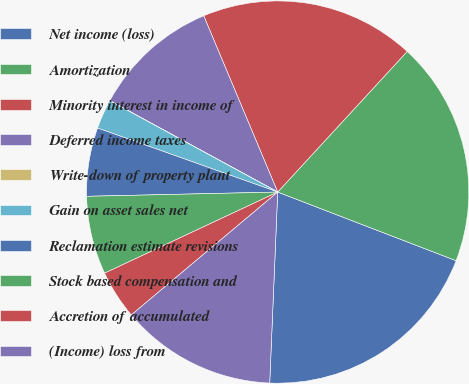Convert chart to OTSL. <chart><loc_0><loc_0><loc_500><loc_500><pie_chart><fcel>Net income (loss)<fcel>Amortization<fcel>Minority interest in income of<fcel>Deferred income taxes<fcel>Write-down of property plant<fcel>Gain on asset sales net<fcel>Reclamation estimate revisions<fcel>Stock based compensation and<fcel>Accretion of accumulated<fcel>(Income) loss from<nl><fcel>19.82%<fcel>19.0%<fcel>18.17%<fcel>10.74%<fcel>0.01%<fcel>2.49%<fcel>5.79%<fcel>6.62%<fcel>4.14%<fcel>13.22%<nl></chart> 